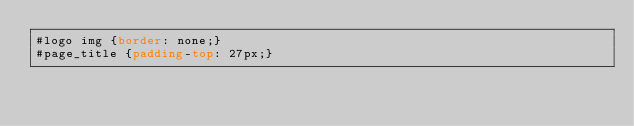Convert code to text. <code><loc_0><loc_0><loc_500><loc_500><_CSS_>#logo img {border: none;}
#page_title {padding-top: 27px;}
</code> 